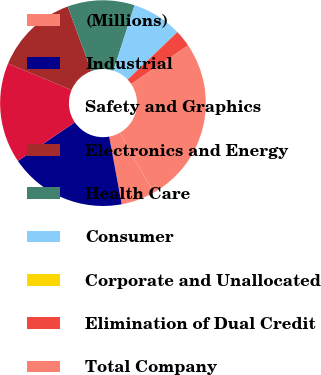<chart> <loc_0><loc_0><loc_500><loc_500><pie_chart><fcel>(Millions)<fcel>Industrial<fcel>Safety and Graphics<fcel>Electronics and Energy<fcel>Health Care<fcel>Consumer<fcel>Corporate and Unallocated<fcel>Elimination of Dual Credit<fcel>Total Company<nl><fcel>5.27%<fcel>18.42%<fcel>15.79%<fcel>13.16%<fcel>10.53%<fcel>7.9%<fcel>0.01%<fcel>2.64%<fcel>26.31%<nl></chart> 